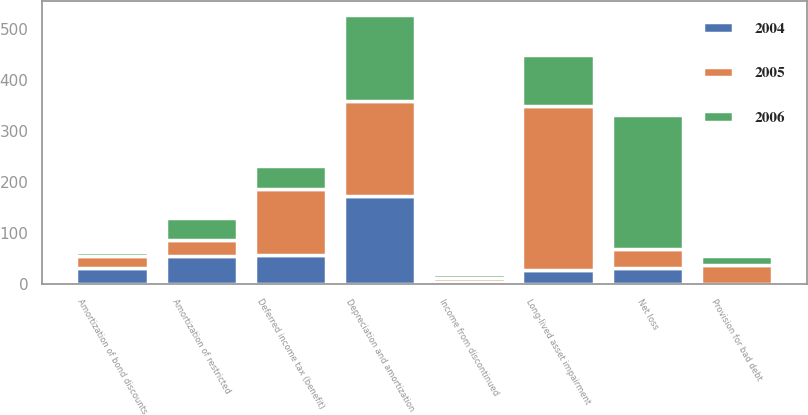<chart> <loc_0><loc_0><loc_500><loc_500><stacked_bar_chart><ecel><fcel>Net loss<fcel>Income from discontinued<fcel>Depreciation and amortization<fcel>Provision for bad debt<fcel>Amortization of restricted<fcel>Amortization of bond discounts<fcel>Deferred income tax (benefit)<fcel>Long-lived asset impairment<nl><fcel>2004<fcel>31.7<fcel>5<fcel>173.6<fcel>1.2<fcel>55.1<fcel>31.8<fcel>57.9<fcel>27.2<nl><fcel>2006<fcel>262.9<fcel>9<fcel>168.8<fcel>16.9<fcel>42.3<fcel>9.1<fcel>44.6<fcel>98.6<nl><fcel>2005<fcel>36.7<fcel>6.5<fcel>185.1<fcel>36.7<fcel>31.4<fcel>22.9<fcel>128.2<fcel>322.2<nl></chart> 